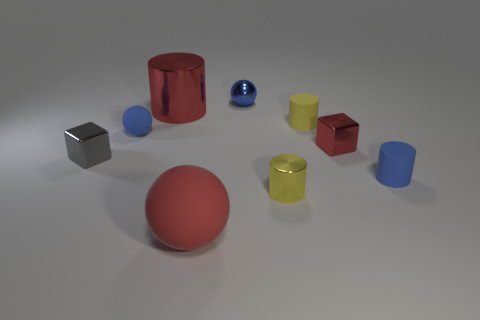Subtract 1 cylinders. How many cylinders are left? 3 Add 1 small brown matte blocks. How many objects exist? 10 Subtract all spheres. How many objects are left? 6 Add 1 small blue things. How many small blue things are left? 4 Add 8 green cylinders. How many green cylinders exist? 8 Subtract 0 cyan cubes. How many objects are left? 9 Subtract all tiny red blocks. Subtract all small gray matte things. How many objects are left? 8 